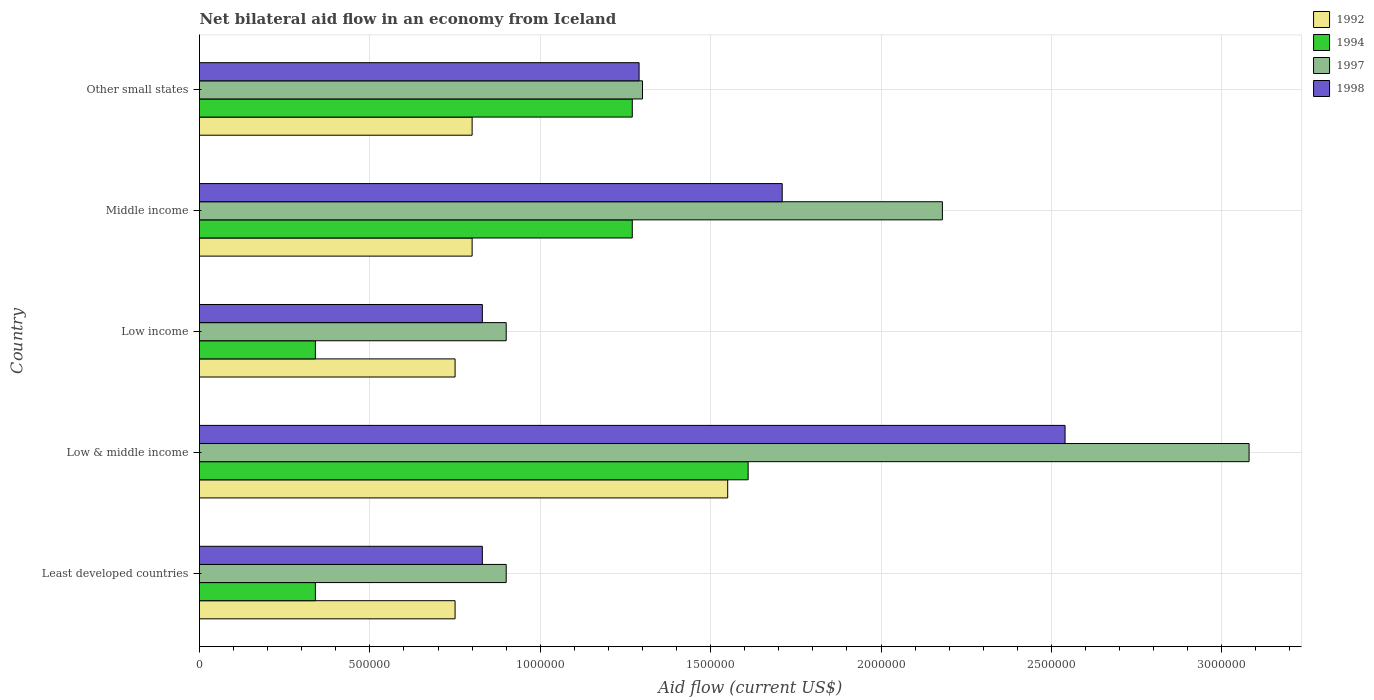Are the number of bars per tick equal to the number of legend labels?
Ensure brevity in your answer.  Yes. Are the number of bars on each tick of the Y-axis equal?
Provide a short and direct response. Yes. How many bars are there on the 4th tick from the top?
Your response must be concise. 4. What is the net bilateral aid flow in 1997 in Least developed countries?
Provide a short and direct response. 9.00e+05. Across all countries, what is the maximum net bilateral aid flow in 1992?
Make the answer very short. 1.55e+06. Across all countries, what is the minimum net bilateral aid flow in 1992?
Give a very brief answer. 7.50e+05. In which country was the net bilateral aid flow in 1994 maximum?
Your answer should be very brief. Low & middle income. In which country was the net bilateral aid flow in 1994 minimum?
Offer a terse response. Least developed countries. What is the total net bilateral aid flow in 1994 in the graph?
Your answer should be very brief. 4.83e+06. What is the difference between the net bilateral aid flow in 1998 in Low income and that in Middle income?
Ensure brevity in your answer.  -8.80e+05. What is the difference between the net bilateral aid flow in 1992 in Least developed countries and the net bilateral aid flow in 1994 in Low income?
Keep it short and to the point. 4.10e+05. What is the average net bilateral aid flow in 1998 per country?
Offer a very short reply. 1.44e+06. What is the difference between the net bilateral aid flow in 1994 and net bilateral aid flow in 1997 in Middle income?
Offer a terse response. -9.10e+05. In how many countries, is the net bilateral aid flow in 1992 greater than 1700000 US$?
Give a very brief answer. 0. What is the ratio of the net bilateral aid flow in 1994 in Low & middle income to that in Other small states?
Offer a very short reply. 1.27. What is the difference between the highest and the second highest net bilateral aid flow in 1998?
Ensure brevity in your answer.  8.30e+05. What is the difference between the highest and the lowest net bilateral aid flow in 1997?
Keep it short and to the point. 2.18e+06. Is it the case that in every country, the sum of the net bilateral aid flow in 1998 and net bilateral aid flow in 1997 is greater than the sum of net bilateral aid flow in 1994 and net bilateral aid flow in 1992?
Make the answer very short. No. What does the 1st bar from the bottom in Low & middle income represents?
Keep it short and to the point. 1992. Is it the case that in every country, the sum of the net bilateral aid flow in 1997 and net bilateral aid flow in 1992 is greater than the net bilateral aid flow in 1998?
Provide a short and direct response. Yes. How many bars are there?
Your answer should be compact. 20. How many countries are there in the graph?
Your answer should be compact. 5. Are the values on the major ticks of X-axis written in scientific E-notation?
Keep it short and to the point. No. Does the graph contain grids?
Your response must be concise. Yes. Where does the legend appear in the graph?
Give a very brief answer. Top right. How many legend labels are there?
Keep it short and to the point. 4. What is the title of the graph?
Give a very brief answer. Net bilateral aid flow in an economy from Iceland. Does "1974" appear as one of the legend labels in the graph?
Provide a succinct answer. No. What is the label or title of the Y-axis?
Provide a succinct answer. Country. What is the Aid flow (current US$) in 1992 in Least developed countries?
Provide a succinct answer. 7.50e+05. What is the Aid flow (current US$) in 1997 in Least developed countries?
Provide a succinct answer. 9.00e+05. What is the Aid flow (current US$) of 1998 in Least developed countries?
Provide a succinct answer. 8.30e+05. What is the Aid flow (current US$) of 1992 in Low & middle income?
Ensure brevity in your answer.  1.55e+06. What is the Aid flow (current US$) of 1994 in Low & middle income?
Your answer should be very brief. 1.61e+06. What is the Aid flow (current US$) of 1997 in Low & middle income?
Provide a succinct answer. 3.08e+06. What is the Aid flow (current US$) of 1998 in Low & middle income?
Ensure brevity in your answer.  2.54e+06. What is the Aid flow (current US$) in 1992 in Low income?
Provide a short and direct response. 7.50e+05. What is the Aid flow (current US$) in 1994 in Low income?
Give a very brief answer. 3.40e+05. What is the Aid flow (current US$) of 1998 in Low income?
Provide a short and direct response. 8.30e+05. What is the Aid flow (current US$) of 1992 in Middle income?
Ensure brevity in your answer.  8.00e+05. What is the Aid flow (current US$) in 1994 in Middle income?
Your answer should be very brief. 1.27e+06. What is the Aid flow (current US$) in 1997 in Middle income?
Ensure brevity in your answer.  2.18e+06. What is the Aid flow (current US$) of 1998 in Middle income?
Provide a succinct answer. 1.71e+06. What is the Aid flow (current US$) in 1992 in Other small states?
Offer a terse response. 8.00e+05. What is the Aid flow (current US$) in 1994 in Other small states?
Offer a terse response. 1.27e+06. What is the Aid flow (current US$) in 1997 in Other small states?
Offer a very short reply. 1.30e+06. What is the Aid flow (current US$) in 1998 in Other small states?
Your answer should be very brief. 1.29e+06. Across all countries, what is the maximum Aid flow (current US$) of 1992?
Provide a succinct answer. 1.55e+06. Across all countries, what is the maximum Aid flow (current US$) in 1994?
Your answer should be very brief. 1.61e+06. Across all countries, what is the maximum Aid flow (current US$) in 1997?
Give a very brief answer. 3.08e+06. Across all countries, what is the maximum Aid flow (current US$) in 1998?
Offer a very short reply. 2.54e+06. Across all countries, what is the minimum Aid flow (current US$) of 1992?
Ensure brevity in your answer.  7.50e+05. Across all countries, what is the minimum Aid flow (current US$) of 1994?
Offer a very short reply. 3.40e+05. Across all countries, what is the minimum Aid flow (current US$) in 1997?
Your answer should be very brief. 9.00e+05. Across all countries, what is the minimum Aid flow (current US$) in 1998?
Provide a short and direct response. 8.30e+05. What is the total Aid flow (current US$) in 1992 in the graph?
Ensure brevity in your answer.  4.65e+06. What is the total Aid flow (current US$) of 1994 in the graph?
Give a very brief answer. 4.83e+06. What is the total Aid flow (current US$) in 1997 in the graph?
Offer a very short reply. 8.36e+06. What is the total Aid flow (current US$) in 1998 in the graph?
Offer a terse response. 7.20e+06. What is the difference between the Aid flow (current US$) in 1992 in Least developed countries and that in Low & middle income?
Provide a succinct answer. -8.00e+05. What is the difference between the Aid flow (current US$) of 1994 in Least developed countries and that in Low & middle income?
Your answer should be very brief. -1.27e+06. What is the difference between the Aid flow (current US$) of 1997 in Least developed countries and that in Low & middle income?
Offer a terse response. -2.18e+06. What is the difference between the Aid flow (current US$) of 1998 in Least developed countries and that in Low & middle income?
Your answer should be very brief. -1.71e+06. What is the difference between the Aid flow (current US$) in 1997 in Least developed countries and that in Low income?
Give a very brief answer. 0. What is the difference between the Aid flow (current US$) of 1992 in Least developed countries and that in Middle income?
Keep it short and to the point. -5.00e+04. What is the difference between the Aid flow (current US$) of 1994 in Least developed countries and that in Middle income?
Your response must be concise. -9.30e+05. What is the difference between the Aid flow (current US$) of 1997 in Least developed countries and that in Middle income?
Provide a succinct answer. -1.28e+06. What is the difference between the Aid flow (current US$) of 1998 in Least developed countries and that in Middle income?
Your answer should be compact. -8.80e+05. What is the difference between the Aid flow (current US$) of 1994 in Least developed countries and that in Other small states?
Provide a short and direct response. -9.30e+05. What is the difference between the Aid flow (current US$) of 1997 in Least developed countries and that in Other small states?
Your response must be concise. -4.00e+05. What is the difference between the Aid flow (current US$) in 1998 in Least developed countries and that in Other small states?
Your answer should be very brief. -4.60e+05. What is the difference between the Aid flow (current US$) of 1994 in Low & middle income and that in Low income?
Make the answer very short. 1.27e+06. What is the difference between the Aid flow (current US$) of 1997 in Low & middle income and that in Low income?
Ensure brevity in your answer.  2.18e+06. What is the difference between the Aid flow (current US$) of 1998 in Low & middle income and that in Low income?
Offer a terse response. 1.71e+06. What is the difference between the Aid flow (current US$) in 1992 in Low & middle income and that in Middle income?
Your answer should be very brief. 7.50e+05. What is the difference between the Aid flow (current US$) in 1998 in Low & middle income and that in Middle income?
Offer a terse response. 8.30e+05. What is the difference between the Aid flow (current US$) of 1992 in Low & middle income and that in Other small states?
Keep it short and to the point. 7.50e+05. What is the difference between the Aid flow (current US$) of 1997 in Low & middle income and that in Other small states?
Offer a terse response. 1.78e+06. What is the difference between the Aid flow (current US$) in 1998 in Low & middle income and that in Other small states?
Offer a terse response. 1.25e+06. What is the difference between the Aid flow (current US$) in 1992 in Low income and that in Middle income?
Keep it short and to the point. -5.00e+04. What is the difference between the Aid flow (current US$) in 1994 in Low income and that in Middle income?
Provide a succinct answer. -9.30e+05. What is the difference between the Aid flow (current US$) of 1997 in Low income and that in Middle income?
Your response must be concise. -1.28e+06. What is the difference between the Aid flow (current US$) in 1998 in Low income and that in Middle income?
Offer a terse response. -8.80e+05. What is the difference between the Aid flow (current US$) of 1994 in Low income and that in Other small states?
Give a very brief answer. -9.30e+05. What is the difference between the Aid flow (current US$) in 1997 in Low income and that in Other small states?
Your response must be concise. -4.00e+05. What is the difference between the Aid flow (current US$) in 1998 in Low income and that in Other small states?
Give a very brief answer. -4.60e+05. What is the difference between the Aid flow (current US$) of 1997 in Middle income and that in Other small states?
Offer a very short reply. 8.80e+05. What is the difference between the Aid flow (current US$) of 1992 in Least developed countries and the Aid flow (current US$) of 1994 in Low & middle income?
Make the answer very short. -8.60e+05. What is the difference between the Aid flow (current US$) in 1992 in Least developed countries and the Aid flow (current US$) in 1997 in Low & middle income?
Give a very brief answer. -2.33e+06. What is the difference between the Aid flow (current US$) in 1992 in Least developed countries and the Aid flow (current US$) in 1998 in Low & middle income?
Offer a terse response. -1.79e+06. What is the difference between the Aid flow (current US$) of 1994 in Least developed countries and the Aid flow (current US$) of 1997 in Low & middle income?
Ensure brevity in your answer.  -2.74e+06. What is the difference between the Aid flow (current US$) in 1994 in Least developed countries and the Aid flow (current US$) in 1998 in Low & middle income?
Your answer should be very brief. -2.20e+06. What is the difference between the Aid flow (current US$) in 1997 in Least developed countries and the Aid flow (current US$) in 1998 in Low & middle income?
Offer a terse response. -1.64e+06. What is the difference between the Aid flow (current US$) in 1992 in Least developed countries and the Aid flow (current US$) in 1994 in Low income?
Give a very brief answer. 4.10e+05. What is the difference between the Aid flow (current US$) in 1994 in Least developed countries and the Aid flow (current US$) in 1997 in Low income?
Keep it short and to the point. -5.60e+05. What is the difference between the Aid flow (current US$) in 1994 in Least developed countries and the Aid flow (current US$) in 1998 in Low income?
Your answer should be compact. -4.90e+05. What is the difference between the Aid flow (current US$) of 1997 in Least developed countries and the Aid flow (current US$) of 1998 in Low income?
Offer a very short reply. 7.00e+04. What is the difference between the Aid flow (current US$) in 1992 in Least developed countries and the Aid flow (current US$) in 1994 in Middle income?
Provide a short and direct response. -5.20e+05. What is the difference between the Aid flow (current US$) of 1992 in Least developed countries and the Aid flow (current US$) of 1997 in Middle income?
Offer a terse response. -1.43e+06. What is the difference between the Aid flow (current US$) of 1992 in Least developed countries and the Aid flow (current US$) of 1998 in Middle income?
Provide a succinct answer. -9.60e+05. What is the difference between the Aid flow (current US$) in 1994 in Least developed countries and the Aid flow (current US$) in 1997 in Middle income?
Give a very brief answer. -1.84e+06. What is the difference between the Aid flow (current US$) in 1994 in Least developed countries and the Aid flow (current US$) in 1998 in Middle income?
Provide a succinct answer. -1.37e+06. What is the difference between the Aid flow (current US$) in 1997 in Least developed countries and the Aid flow (current US$) in 1998 in Middle income?
Keep it short and to the point. -8.10e+05. What is the difference between the Aid flow (current US$) in 1992 in Least developed countries and the Aid flow (current US$) in 1994 in Other small states?
Give a very brief answer. -5.20e+05. What is the difference between the Aid flow (current US$) in 1992 in Least developed countries and the Aid flow (current US$) in 1997 in Other small states?
Ensure brevity in your answer.  -5.50e+05. What is the difference between the Aid flow (current US$) in 1992 in Least developed countries and the Aid flow (current US$) in 1998 in Other small states?
Make the answer very short. -5.40e+05. What is the difference between the Aid flow (current US$) in 1994 in Least developed countries and the Aid flow (current US$) in 1997 in Other small states?
Offer a terse response. -9.60e+05. What is the difference between the Aid flow (current US$) in 1994 in Least developed countries and the Aid flow (current US$) in 1998 in Other small states?
Keep it short and to the point. -9.50e+05. What is the difference between the Aid flow (current US$) of 1997 in Least developed countries and the Aid flow (current US$) of 1998 in Other small states?
Give a very brief answer. -3.90e+05. What is the difference between the Aid flow (current US$) in 1992 in Low & middle income and the Aid flow (current US$) in 1994 in Low income?
Your answer should be compact. 1.21e+06. What is the difference between the Aid flow (current US$) in 1992 in Low & middle income and the Aid flow (current US$) in 1997 in Low income?
Give a very brief answer. 6.50e+05. What is the difference between the Aid flow (current US$) of 1992 in Low & middle income and the Aid flow (current US$) of 1998 in Low income?
Your response must be concise. 7.20e+05. What is the difference between the Aid flow (current US$) of 1994 in Low & middle income and the Aid flow (current US$) of 1997 in Low income?
Ensure brevity in your answer.  7.10e+05. What is the difference between the Aid flow (current US$) of 1994 in Low & middle income and the Aid flow (current US$) of 1998 in Low income?
Keep it short and to the point. 7.80e+05. What is the difference between the Aid flow (current US$) of 1997 in Low & middle income and the Aid flow (current US$) of 1998 in Low income?
Keep it short and to the point. 2.25e+06. What is the difference between the Aid flow (current US$) in 1992 in Low & middle income and the Aid flow (current US$) in 1997 in Middle income?
Give a very brief answer. -6.30e+05. What is the difference between the Aid flow (current US$) of 1994 in Low & middle income and the Aid flow (current US$) of 1997 in Middle income?
Your answer should be compact. -5.70e+05. What is the difference between the Aid flow (current US$) in 1997 in Low & middle income and the Aid flow (current US$) in 1998 in Middle income?
Your response must be concise. 1.37e+06. What is the difference between the Aid flow (current US$) of 1994 in Low & middle income and the Aid flow (current US$) of 1998 in Other small states?
Your response must be concise. 3.20e+05. What is the difference between the Aid flow (current US$) of 1997 in Low & middle income and the Aid flow (current US$) of 1998 in Other small states?
Offer a terse response. 1.79e+06. What is the difference between the Aid flow (current US$) in 1992 in Low income and the Aid flow (current US$) in 1994 in Middle income?
Ensure brevity in your answer.  -5.20e+05. What is the difference between the Aid flow (current US$) of 1992 in Low income and the Aid flow (current US$) of 1997 in Middle income?
Ensure brevity in your answer.  -1.43e+06. What is the difference between the Aid flow (current US$) in 1992 in Low income and the Aid flow (current US$) in 1998 in Middle income?
Your answer should be compact. -9.60e+05. What is the difference between the Aid flow (current US$) of 1994 in Low income and the Aid flow (current US$) of 1997 in Middle income?
Offer a terse response. -1.84e+06. What is the difference between the Aid flow (current US$) in 1994 in Low income and the Aid flow (current US$) in 1998 in Middle income?
Make the answer very short. -1.37e+06. What is the difference between the Aid flow (current US$) of 1997 in Low income and the Aid flow (current US$) of 1998 in Middle income?
Give a very brief answer. -8.10e+05. What is the difference between the Aid flow (current US$) in 1992 in Low income and the Aid flow (current US$) in 1994 in Other small states?
Offer a terse response. -5.20e+05. What is the difference between the Aid flow (current US$) of 1992 in Low income and the Aid flow (current US$) of 1997 in Other small states?
Ensure brevity in your answer.  -5.50e+05. What is the difference between the Aid flow (current US$) in 1992 in Low income and the Aid flow (current US$) in 1998 in Other small states?
Your response must be concise. -5.40e+05. What is the difference between the Aid flow (current US$) of 1994 in Low income and the Aid flow (current US$) of 1997 in Other small states?
Keep it short and to the point. -9.60e+05. What is the difference between the Aid flow (current US$) of 1994 in Low income and the Aid flow (current US$) of 1998 in Other small states?
Your answer should be very brief. -9.50e+05. What is the difference between the Aid flow (current US$) in 1997 in Low income and the Aid flow (current US$) in 1998 in Other small states?
Offer a terse response. -3.90e+05. What is the difference between the Aid flow (current US$) of 1992 in Middle income and the Aid flow (current US$) of 1994 in Other small states?
Offer a very short reply. -4.70e+05. What is the difference between the Aid flow (current US$) in 1992 in Middle income and the Aid flow (current US$) in 1997 in Other small states?
Offer a terse response. -5.00e+05. What is the difference between the Aid flow (current US$) in 1992 in Middle income and the Aid flow (current US$) in 1998 in Other small states?
Your response must be concise. -4.90e+05. What is the difference between the Aid flow (current US$) in 1997 in Middle income and the Aid flow (current US$) in 1998 in Other small states?
Offer a very short reply. 8.90e+05. What is the average Aid flow (current US$) in 1992 per country?
Give a very brief answer. 9.30e+05. What is the average Aid flow (current US$) of 1994 per country?
Provide a short and direct response. 9.66e+05. What is the average Aid flow (current US$) of 1997 per country?
Give a very brief answer. 1.67e+06. What is the average Aid flow (current US$) of 1998 per country?
Make the answer very short. 1.44e+06. What is the difference between the Aid flow (current US$) in 1992 and Aid flow (current US$) in 1997 in Least developed countries?
Make the answer very short. -1.50e+05. What is the difference between the Aid flow (current US$) of 1992 and Aid flow (current US$) of 1998 in Least developed countries?
Keep it short and to the point. -8.00e+04. What is the difference between the Aid flow (current US$) in 1994 and Aid flow (current US$) in 1997 in Least developed countries?
Ensure brevity in your answer.  -5.60e+05. What is the difference between the Aid flow (current US$) of 1994 and Aid flow (current US$) of 1998 in Least developed countries?
Offer a very short reply. -4.90e+05. What is the difference between the Aid flow (current US$) of 1997 and Aid flow (current US$) of 1998 in Least developed countries?
Provide a succinct answer. 7.00e+04. What is the difference between the Aid flow (current US$) of 1992 and Aid flow (current US$) of 1997 in Low & middle income?
Make the answer very short. -1.53e+06. What is the difference between the Aid flow (current US$) of 1992 and Aid flow (current US$) of 1998 in Low & middle income?
Provide a short and direct response. -9.90e+05. What is the difference between the Aid flow (current US$) of 1994 and Aid flow (current US$) of 1997 in Low & middle income?
Your answer should be compact. -1.47e+06. What is the difference between the Aid flow (current US$) in 1994 and Aid flow (current US$) in 1998 in Low & middle income?
Offer a terse response. -9.30e+05. What is the difference between the Aid flow (current US$) in 1997 and Aid flow (current US$) in 1998 in Low & middle income?
Ensure brevity in your answer.  5.40e+05. What is the difference between the Aid flow (current US$) in 1992 and Aid flow (current US$) in 1994 in Low income?
Your answer should be compact. 4.10e+05. What is the difference between the Aid flow (current US$) in 1992 and Aid flow (current US$) in 1997 in Low income?
Provide a short and direct response. -1.50e+05. What is the difference between the Aid flow (current US$) of 1992 and Aid flow (current US$) of 1998 in Low income?
Make the answer very short. -8.00e+04. What is the difference between the Aid flow (current US$) in 1994 and Aid flow (current US$) in 1997 in Low income?
Offer a terse response. -5.60e+05. What is the difference between the Aid flow (current US$) in 1994 and Aid flow (current US$) in 1998 in Low income?
Ensure brevity in your answer.  -4.90e+05. What is the difference between the Aid flow (current US$) of 1997 and Aid flow (current US$) of 1998 in Low income?
Provide a short and direct response. 7.00e+04. What is the difference between the Aid flow (current US$) of 1992 and Aid flow (current US$) of 1994 in Middle income?
Ensure brevity in your answer.  -4.70e+05. What is the difference between the Aid flow (current US$) of 1992 and Aid flow (current US$) of 1997 in Middle income?
Provide a short and direct response. -1.38e+06. What is the difference between the Aid flow (current US$) in 1992 and Aid flow (current US$) in 1998 in Middle income?
Provide a succinct answer. -9.10e+05. What is the difference between the Aid flow (current US$) of 1994 and Aid flow (current US$) of 1997 in Middle income?
Make the answer very short. -9.10e+05. What is the difference between the Aid flow (current US$) in 1994 and Aid flow (current US$) in 1998 in Middle income?
Your response must be concise. -4.40e+05. What is the difference between the Aid flow (current US$) of 1992 and Aid flow (current US$) of 1994 in Other small states?
Make the answer very short. -4.70e+05. What is the difference between the Aid flow (current US$) of 1992 and Aid flow (current US$) of 1997 in Other small states?
Provide a succinct answer. -5.00e+05. What is the difference between the Aid flow (current US$) of 1992 and Aid flow (current US$) of 1998 in Other small states?
Provide a succinct answer. -4.90e+05. What is the difference between the Aid flow (current US$) in 1994 and Aid flow (current US$) in 1997 in Other small states?
Ensure brevity in your answer.  -3.00e+04. What is the difference between the Aid flow (current US$) in 1994 and Aid flow (current US$) in 1998 in Other small states?
Offer a terse response. -2.00e+04. What is the ratio of the Aid flow (current US$) of 1992 in Least developed countries to that in Low & middle income?
Your response must be concise. 0.48. What is the ratio of the Aid flow (current US$) of 1994 in Least developed countries to that in Low & middle income?
Keep it short and to the point. 0.21. What is the ratio of the Aid flow (current US$) of 1997 in Least developed countries to that in Low & middle income?
Offer a terse response. 0.29. What is the ratio of the Aid flow (current US$) in 1998 in Least developed countries to that in Low & middle income?
Give a very brief answer. 0.33. What is the ratio of the Aid flow (current US$) of 1992 in Least developed countries to that in Low income?
Your answer should be compact. 1. What is the ratio of the Aid flow (current US$) of 1998 in Least developed countries to that in Low income?
Keep it short and to the point. 1. What is the ratio of the Aid flow (current US$) in 1994 in Least developed countries to that in Middle income?
Ensure brevity in your answer.  0.27. What is the ratio of the Aid flow (current US$) of 1997 in Least developed countries to that in Middle income?
Your answer should be very brief. 0.41. What is the ratio of the Aid flow (current US$) of 1998 in Least developed countries to that in Middle income?
Your answer should be very brief. 0.49. What is the ratio of the Aid flow (current US$) in 1992 in Least developed countries to that in Other small states?
Give a very brief answer. 0.94. What is the ratio of the Aid flow (current US$) of 1994 in Least developed countries to that in Other small states?
Keep it short and to the point. 0.27. What is the ratio of the Aid flow (current US$) of 1997 in Least developed countries to that in Other small states?
Offer a very short reply. 0.69. What is the ratio of the Aid flow (current US$) in 1998 in Least developed countries to that in Other small states?
Provide a succinct answer. 0.64. What is the ratio of the Aid flow (current US$) in 1992 in Low & middle income to that in Low income?
Offer a terse response. 2.07. What is the ratio of the Aid flow (current US$) in 1994 in Low & middle income to that in Low income?
Keep it short and to the point. 4.74. What is the ratio of the Aid flow (current US$) of 1997 in Low & middle income to that in Low income?
Give a very brief answer. 3.42. What is the ratio of the Aid flow (current US$) in 1998 in Low & middle income to that in Low income?
Offer a terse response. 3.06. What is the ratio of the Aid flow (current US$) in 1992 in Low & middle income to that in Middle income?
Your answer should be compact. 1.94. What is the ratio of the Aid flow (current US$) in 1994 in Low & middle income to that in Middle income?
Give a very brief answer. 1.27. What is the ratio of the Aid flow (current US$) in 1997 in Low & middle income to that in Middle income?
Provide a succinct answer. 1.41. What is the ratio of the Aid flow (current US$) in 1998 in Low & middle income to that in Middle income?
Make the answer very short. 1.49. What is the ratio of the Aid flow (current US$) in 1992 in Low & middle income to that in Other small states?
Provide a succinct answer. 1.94. What is the ratio of the Aid flow (current US$) in 1994 in Low & middle income to that in Other small states?
Make the answer very short. 1.27. What is the ratio of the Aid flow (current US$) of 1997 in Low & middle income to that in Other small states?
Make the answer very short. 2.37. What is the ratio of the Aid flow (current US$) in 1998 in Low & middle income to that in Other small states?
Make the answer very short. 1.97. What is the ratio of the Aid flow (current US$) of 1994 in Low income to that in Middle income?
Provide a short and direct response. 0.27. What is the ratio of the Aid flow (current US$) of 1997 in Low income to that in Middle income?
Provide a succinct answer. 0.41. What is the ratio of the Aid flow (current US$) of 1998 in Low income to that in Middle income?
Make the answer very short. 0.49. What is the ratio of the Aid flow (current US$) in 1994 in Low income to that in Other small states?
Your answer should be very brief. 0.27. What is the ratio of the Aid flow (current US$) in 1997 in Low income to that in Other small states?
Your answer should be very brief. 0.69. What is the ratio of the Aid flow (current US$) in 1998 in Low income to that in Other small states?
Offer a very short reply. 0.64. What is the ratio of the Aid flow (current US$) in 1997 in Middle income to that in Other small states?
Make the answer very short. 1.68. What is the ratio of the Aid flow (current US$) of 1998 in Middle income to that in Other small states?
Give a very brief answer. 1.33. What is the difference between the highest and the second highest Aid flow (current US$) in 1992?
Give a very brief answer. 7.50e+05. What is the difference between the highest and the second highest Aid flow (current US$) of 1997?
Your answer should be compact. 9.00e+05. What is the difference between the highest and the second highest Aid flow (current US$) in 1998?
Provide a short and direct response. 8.30e+05. What is the difference between the highest and the lowest Aid flow (current US$) of 1994?
Make the answer very short. 1.27e+06. What is the difference between the highest and the lowest Aid flow (current US$) in 1997?
Provide a succinct answer. 2.18e+06. What is the difference between the highest and the lowest Aid flow (current US$) in 1998?
Your answer should be very brief. 1.71e+06. 